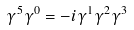Convert formula to latex. <formula><loc_0><loc_0><loc_500><loc_500>\gamma ^ { 5 } \gamma ^ { 0 } = - i \gamma ^ { 1 } \gamma ^ { 2 } \gamma ^ { 3 }</formula> 